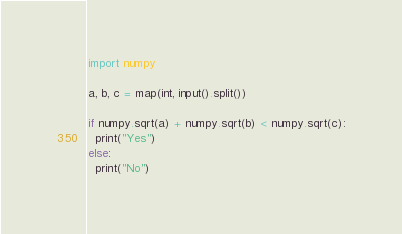<code> <loc_0><loc_0><loc_500><loc_500><_Python_>import numpy
 
a, b, c = map(int, input().split())
 
if numpy.sqrt(a) + numpy.sqrt(b) < numpy.sqrt(c):
  print("Yes")
else:
  print("No")</code> 